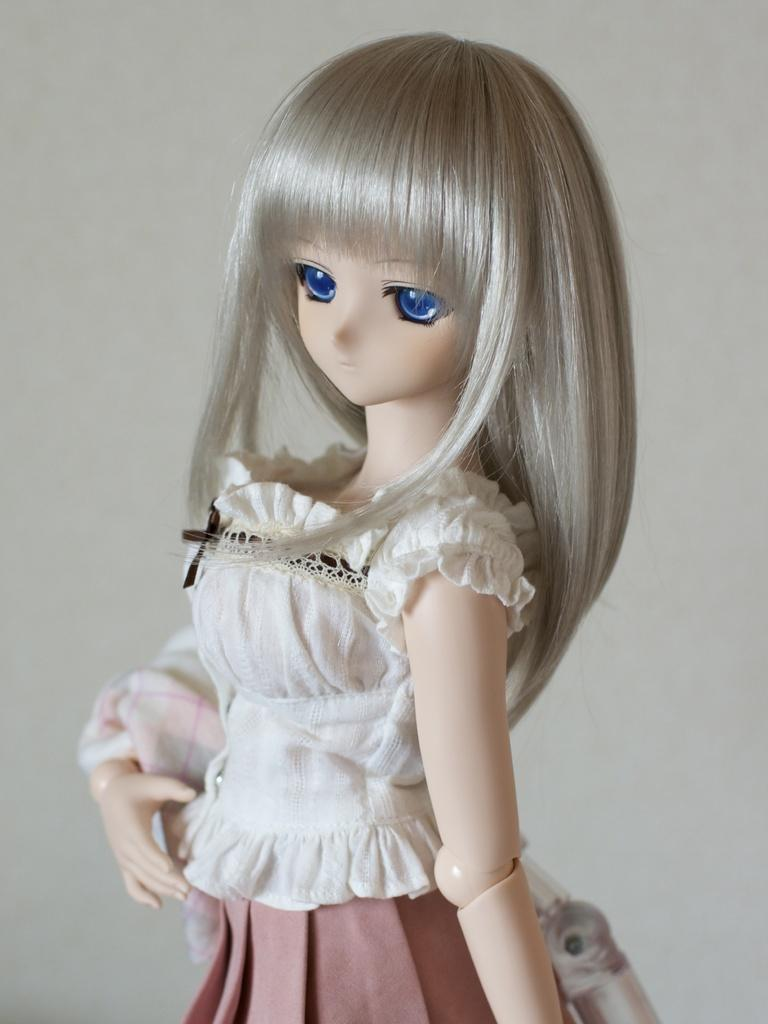What is the main subject of the image? There is a doll in the image. What color is the background of the image? The background of the image is white. What type of sail can be seen on the kettle in the image? There is no sail or kettle present in the image; it only features a doll. How is the glue being used in the image? There is no glue present in the image, so it cannot be determined how it might be used. 